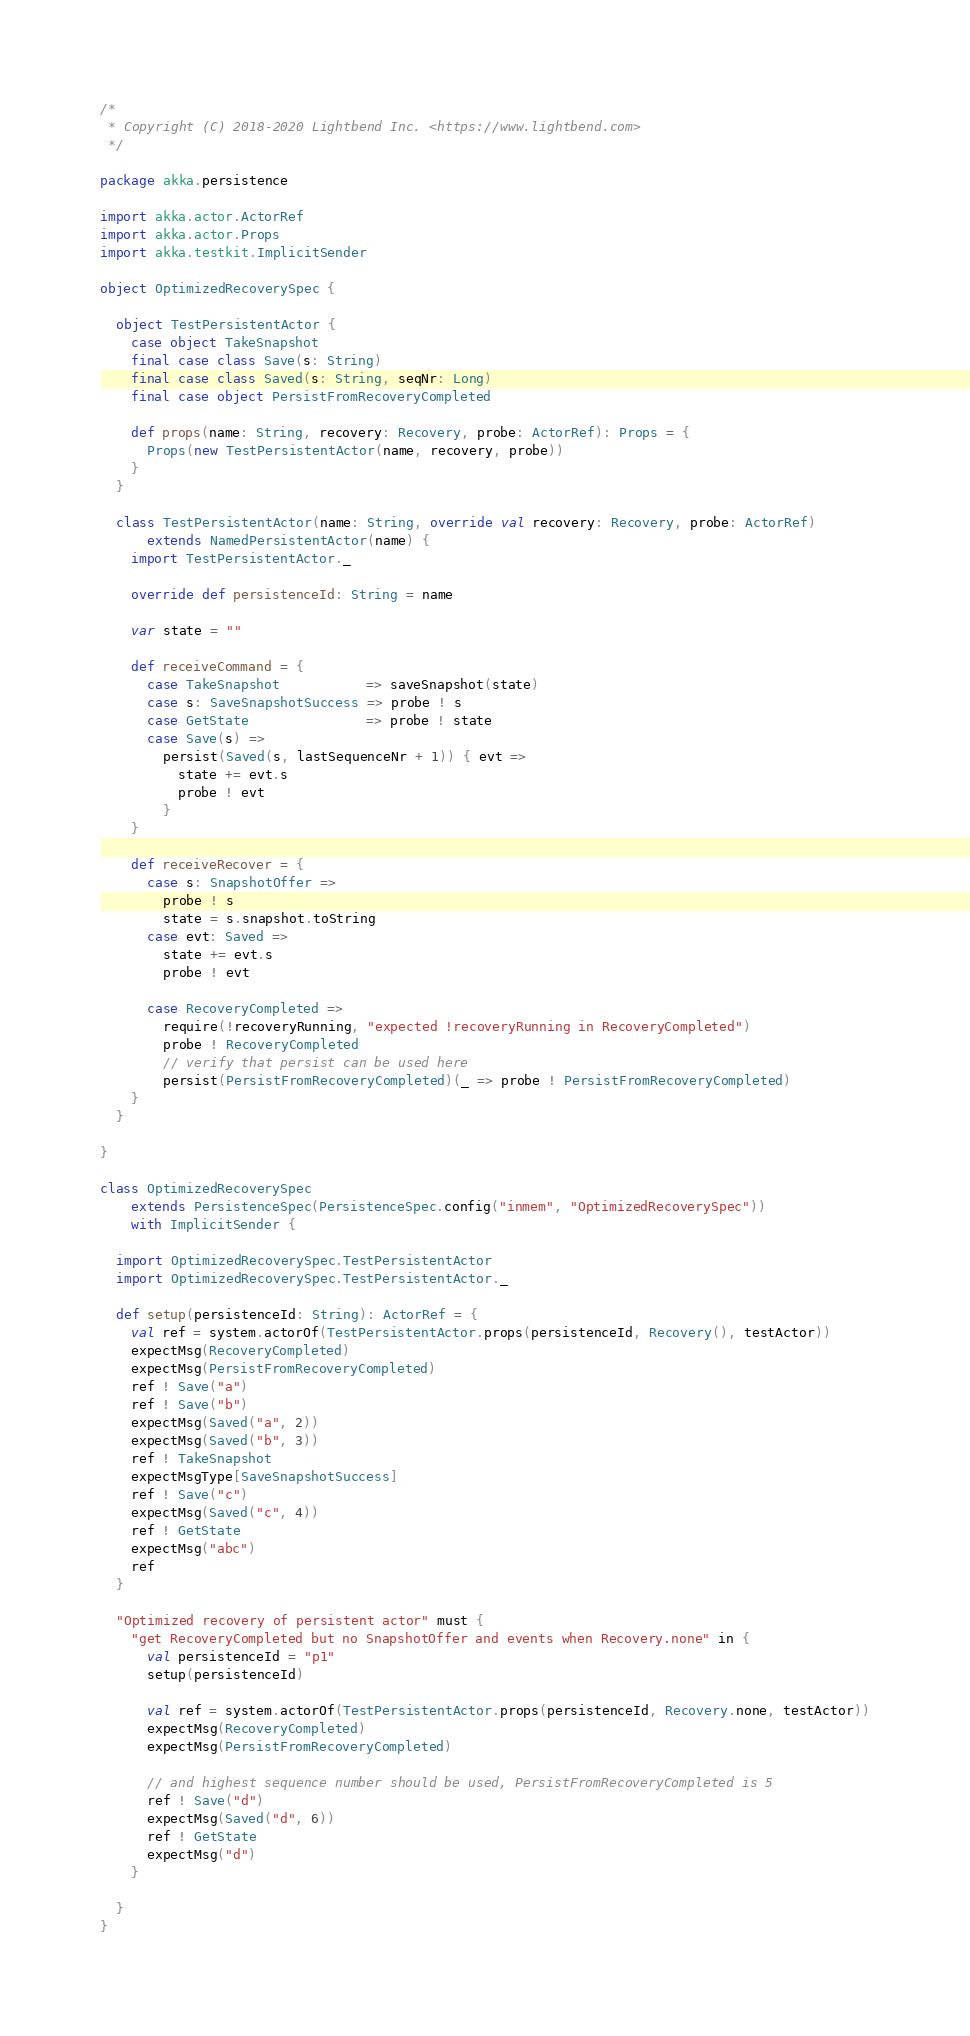Convert code to text. <code><loc_0><loc_0><loc_500><loc_500><_Scala_>/*
 * Copyright (C) 2018-2020 Lightbend Inc. <https://www.lightbend.com>
 */

package akka.persistence

import akka.actor.ActorRef
import akka.actor.Props
import akka.testkit.ImplicitSender

object OptimizedRecoverySpec {

  object TestPersistentActor {
    case object TakeSnapshot
    final case class Save(s: String)
    final case class Saved(s: String, seqNr: Long)
    final case object PersistFromRecoveryCompleted

    def props(name: String, recovery: Recovery, probe: ActorRef): Props = {
      Props(new TestPersistentActor(name, recovery, probe))
    }
  }

  class TestPersistentActor(name: String, override val recovery: Recovery, probe: ActorRef)
      extends NamedPersistentActor(name) {
    import TestPersistentActor._

    override def persistenceId: String = name

    var state = ""

    def receiveCommand = {
      case TakeSnapshot           => saveSnapshot(state)
      case s: SaveSnapshotSuccess => probe ! s
      case GetState               => probe ! state
      case Save(s) =>
        persist(Saved(s, lastSequenceNr + 1)) { evt =>
          state += evt.s
          probe ! evt
        }
    }

    def receiveRecover = {
      case s: SnapshotOffer =>
        probe ! s
        state = s.snapshot.toString
      case evt: Saved =>
        state += evt.s
        probe ! evt

      case RecoveryCompleted =>
        require(!recoveryRunning, "expected !recoveryRunning in RecoveryCompleted")
        probe ! RecoveryCompleted
        // verify that persist can be used here
        persist(PersistFromRecoveryCompleted)(_ => probe ! PersistFromRecoveryCompleted)
    }
  }

}

class OptimizedRecoverySpec
    extends PersistenceSpec(PersistenceSpec.config("inmem", "OptimizedRecoverySpec"))
    with ImplicitSender {

  import OptimizedRecoverySpec.TestPersistentActor
  import OptimizedRecoverySpec.TestPersistentActor._

  def setup(persistenceId: String): ActorRef = {
    val ref = system.actorOf(TestPersistentActor.props(persistenceId, Recovery(), testActor))
    expectMsg(RecoveryCompleted)
    expectMsg(PersistFromRecoveryCompleted)
    ref ! Save("a")
    ref ! Save("b")
    expectMsg(Saved("a", 2))
    expectMsg(Saved("b", 3))
    ref ! TakeSnapshot
    expectMsgType[SaveSnapshotSuccess]
    ref ! Save("c")
    expectMsg(Saved("c", 4))
    ref ! GetState
    expectMsg("abc")
    ref
  }

  "Optimized recovery of persistent actor" must {
    "get RecoveryCompleted but no SnapshotOffer and events when Recovery.none" in {
      val persistenceId = "p1"
      setup(persistenceId)

      val ref = system.actorOf(TestPersistentActor.props(persistenceId, Recovery.none, testActor))
      expectMsg(RecoveryCompleted)
      expectMsg(PersistFromRecoveryCompleted)

      // and highest sequence number should be used, PersistFromRecoveryCompleted is 5
      ref ! Save("d")
      expectMsg(Saved("d", 6))
      ref ! GetState
      expectMsg("d")
    }

  }
}
</code> 